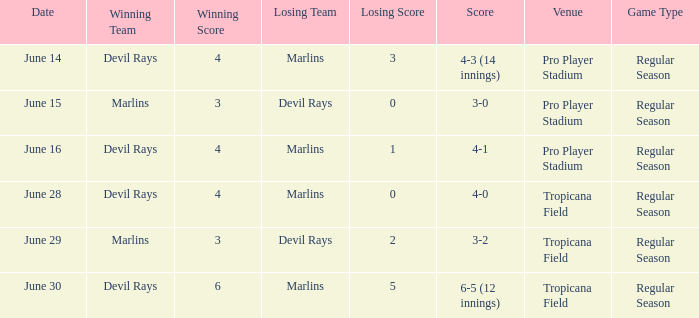What was the score of the game at pro player stadium on june 14? 4-3 (14 innings). 